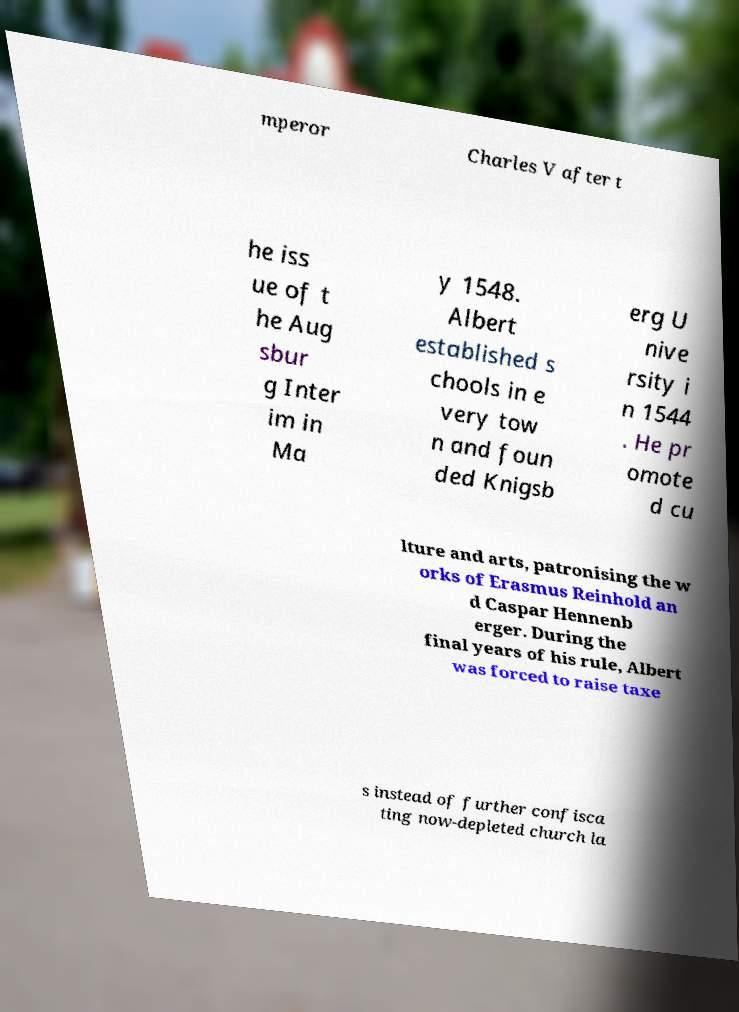Could you extract and type out the text from this image? mperor Charles V after t he iss ue of t he Aug sbur g Inter im in Ma y 1548. Albert established s chools in e very tow n and foun ded Knigsb erg U nive rsity i n 1544 . He pr omote d cu lture and arts, patronising the w orks of Erasmus Reinhold an d Caspar Hennenb erger. During the final years of his rule, Albert was forced to raise taxe s instead of further confisca ting now-depleted church la 